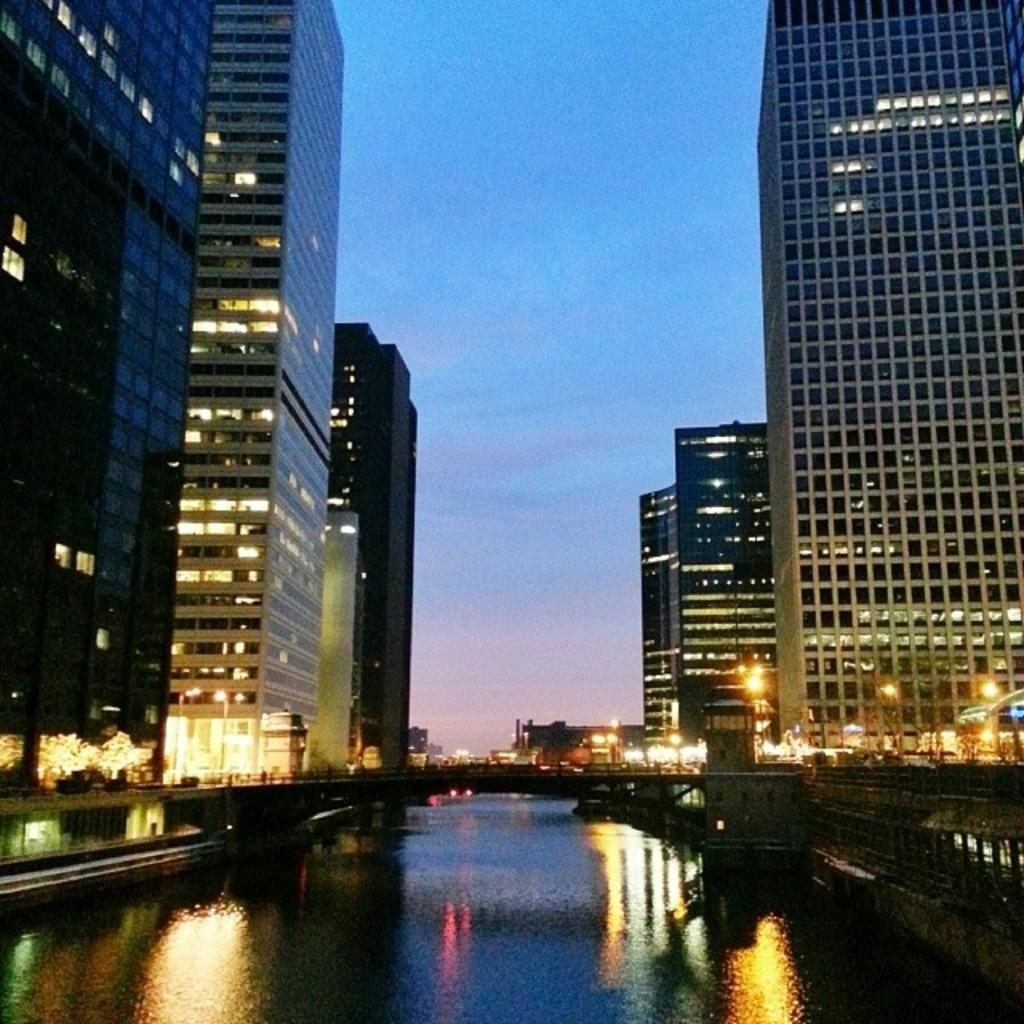What is the main feature in the center of the image? There is water in the center of the image. What structure can be seen crossing over the water? There is a bridge in the image. What type of structures are visible on both sides of the water? There are buildings on both sides of the image. What is visible above the water and buildings? The sky is visible at the top of the image. What type of friction can be seen between the water and the bridge in the image? There is no friction visible between the water and the bridge in the image. The image is a still representation and does not show any movement or interaction between the water and the bridge. 